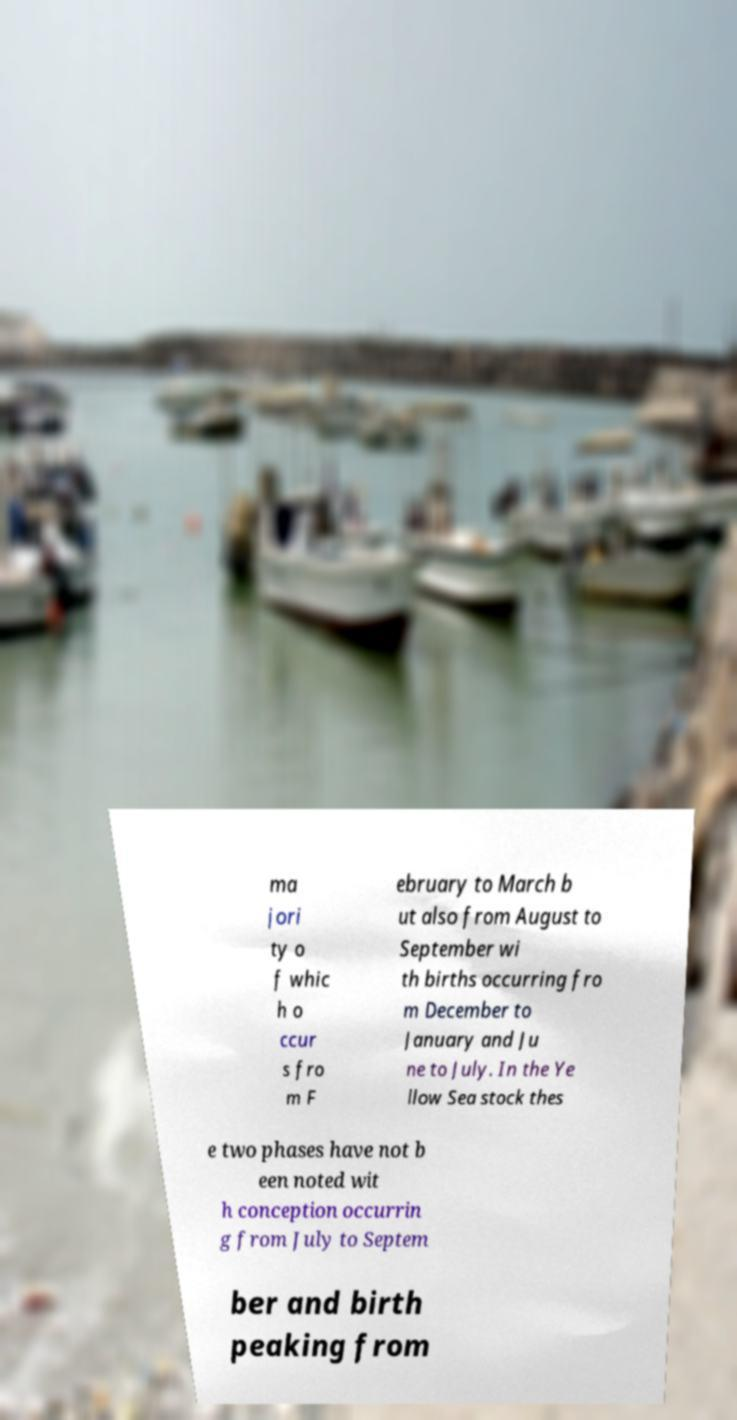Could you assist in decoding the text presented in this image and type it out clearly? ma jori ty o f whic h o ccur s fro m F ebruary to March b ut also from August to September wi th births occurring fro m December to January and Ju ne to July. In the Ye llow Sea stock thes e two phases have not b een noted wit h conception occurrin g from July to Septem ber and birth peaking from 